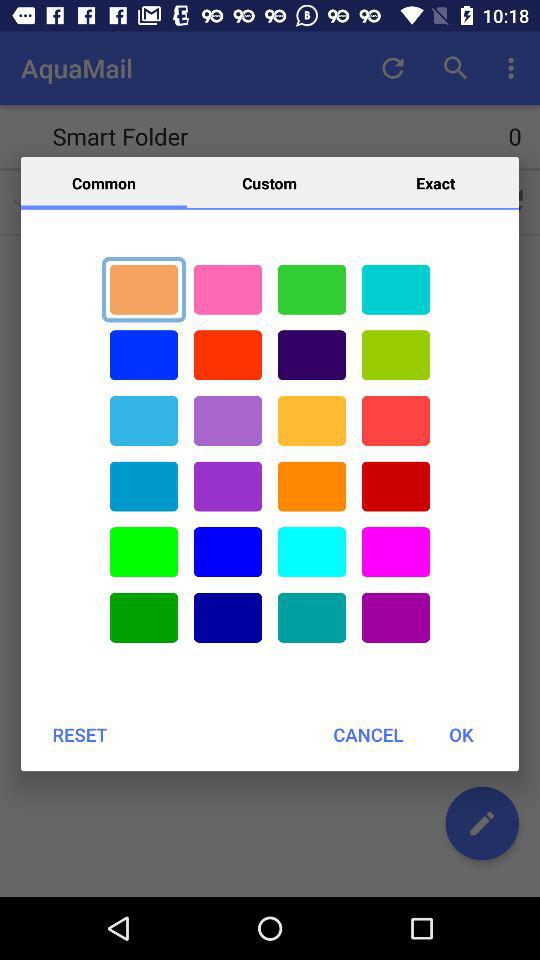What is the selected color?
When the provided information is insufficient, respond with <no answer>. <no answer> 